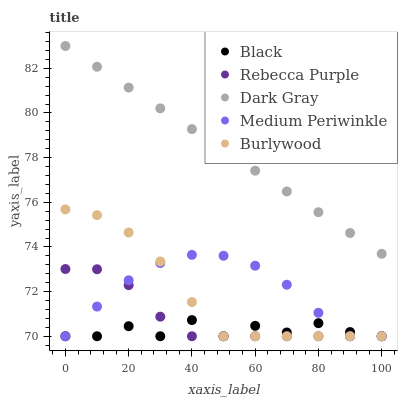Does Black have the minimum area under the curve?
Answer yes or no. Yes. Does Dark Gray have the maximum area under the curve?
Answer yes or no. Yes. Does Medium Periwinkle have the minimum area under the curve?
Answer yes or no. No. Does Medium Periwinkle have the maximum area under the curve?
Answer yes or no. No. Is Dark Gray the smoothest?
Answer yes or no. Yes. Is Black the roughest?
Answer yes or no. Yes. Is Medium Periwinkle the smoothest?
Answer yes or no. No. Is Medium Periwinkle the roughest?
Answer yes or no. No. Does Medium Periwinkle have the lowest value?
Answer yes or no. Yes. Does Dark Gray have the highest value?
Answer yes or no. Yes. Does Medium Periwinkle have the highest value?
Answer yes or no. No. Is Rebecca Purple less than Dark Gray?
Answer yes or no. Yes. Is Dark Gray greater than Rebecca Purple?
Answer yes or no. Yes. Does Black intersect Medium Periwinkle?
Answer yes or no. Yes. Is Black less than Medium Periwinkle?
Answer yes or no. No. Is Black greater than Medium Periwinkle?
Answer yes or no. No. Does Rebecca Purple intersect Dark Gray?
Answer yes or no. No. 